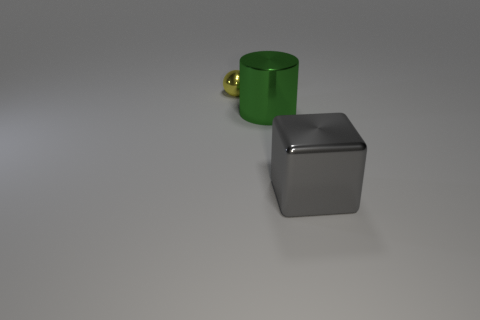The big cube has what color?
Your answer should be compact. Gray. How many objects are large yellow things or things that are right of the large green object?
Offer a terse response. 1. Do the big object to the left of the large gray thing and the small yellow object have the same material?
Keep it short and to the point. Yes. Are there any other things that have the same size as the yellow ball?
Provide a short and direct response. No. There is a thing on the right side of the big metal object behind the big gray shiny thing; what is its material?
Offer a very short reply. Metal. Is the number of small yellow metallic things that are in front of the tiny yellow thing greater than the number of small yellow balls that are right of the big gray block?
Your response must be concise. No. What is the size of the green metal cylinder?
Keep it short and to the point. Large. There is a object in front of the large green object; is its color the same as the small ball?
Provide a short and direct response. No. Are there any other things that have the same shape as the green metallic object?
Make the answer very short. No. Are there any gray cubes to the left of the big metallic object to the right of the green cylinder?
Offer a very short reply. No. 